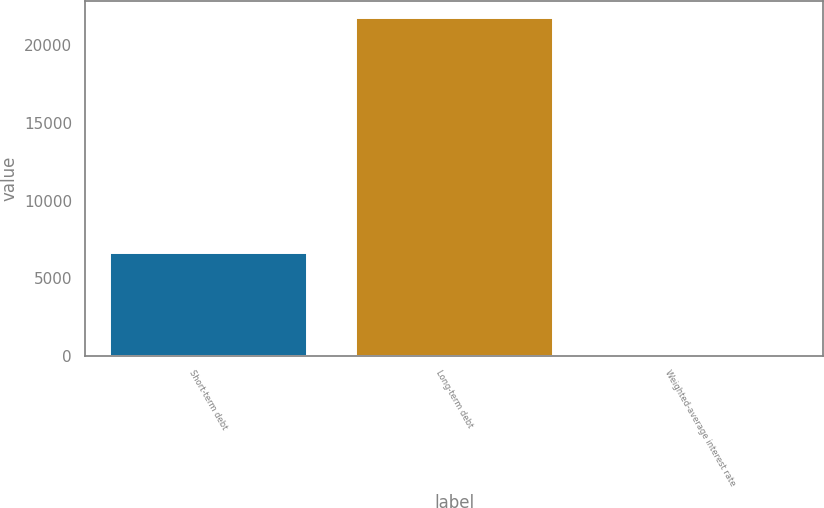<chart> <loc_0><loc_0><loc_500><loc_500><bar_chart><fcel>Short-term debt<fcel>Long-term debt<fcel>Weighted-average interest rate<nl><fcel>6647<fcel>21789<fcel>3<nl></chart> 